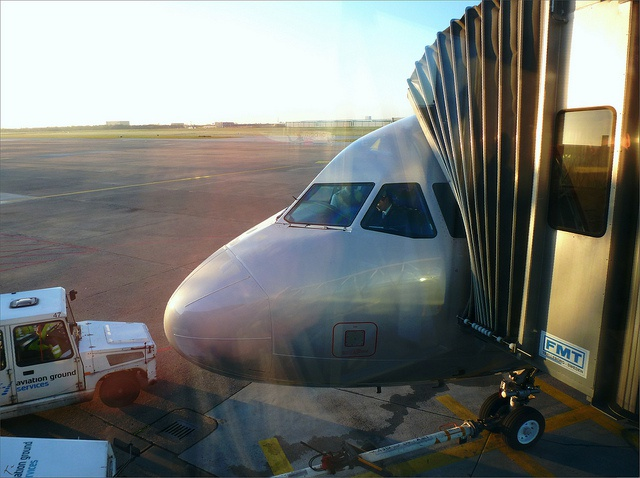Describe the objects in this image and their specific colors. I can see airplane in darkgray, black, and gray tones, truck in darkgray, gray, black, lightblue, and maroon tones, people in darkgray, black, navy, teal, and gray tones, people in darkgray, black, gray, and darkgreen tones, and people in darkgray, blue, navy, and teal tones in this image. 